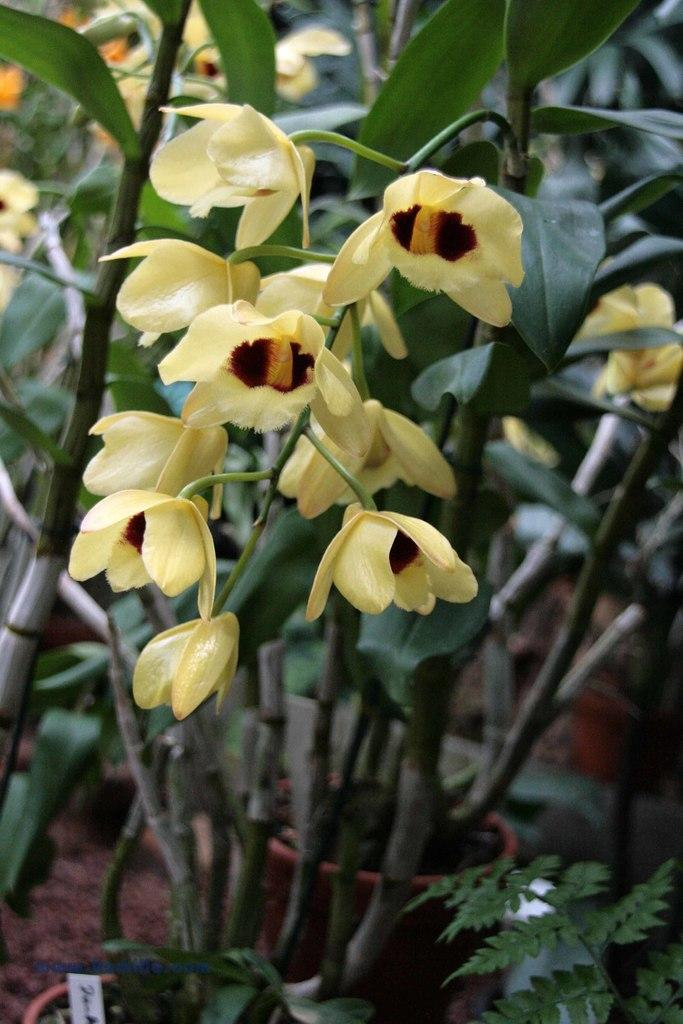What type of flora can be seen in the image? There are beautiful flowers in the image. Are the flowers part of a larger plant or organism? Yes, the flowers are on plants. What is the condition of the porter in the image? There is no porter present in the image; it only features beautiful flowers on plants. 